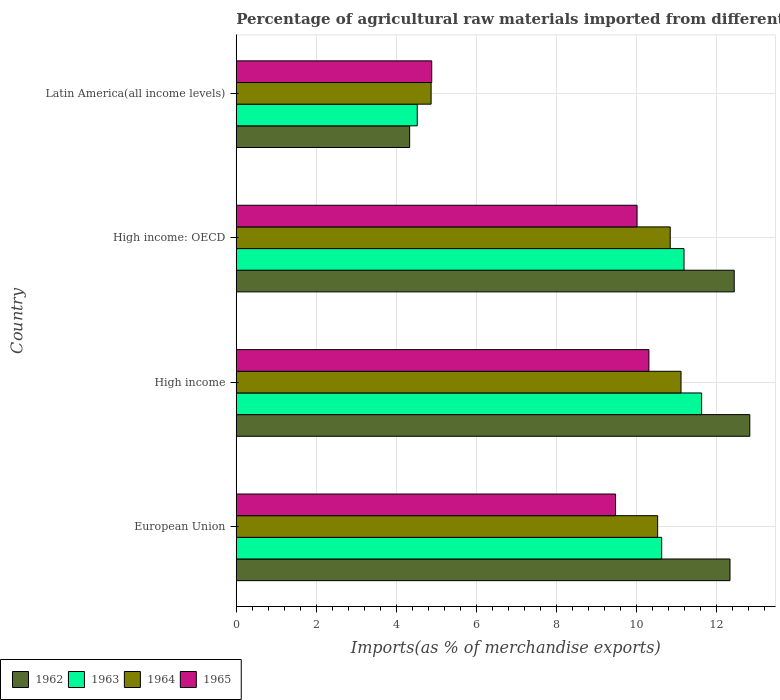How many different coloured bars are there?
Provide a succinct answer. 4. How many bars are there on the 2nd tick from the top?
Give a very brief answer. 4. How many bars are there on the 1st tick from the bottom?
Keep it short and to the point. 4. What is the percentage of imports to different countries in 1965 in High income: OECD?
Make the answer very short. 10.02. Across all countries, what is the maximum percentage of imports to different countries in 1964?
Your answer should be compact. 11.12. Across all countries, what is the minimum percentage of imports to different countries in 1963?
Your answer should be compact. 4.52. In which country was the percentage of imports to different countries in 1963 maximum?
Provide a succinct answer. High income. In which country was the percentage of imports to different countries in 1963 minimum?
Provide a succinct answer. Latin America(all income levels). What is the total percentage of imports to different countries in 1964 in the graph?
Your response must be concise. 37.37. What is the difference between the percentage of imports to different countries in 1964 in European Union and that in High income: OECD?
Your answer should be compact. -0.31. What is the difference between the percentage of imports to different countries in 1962 in Latin America(all income levels) and the percentage of imports to different countries in 1964 in High income?
Your answer should be compact. -6.78. What is the average percentage of imports to different countries in 1962 per country?
Give a very brief answer. 10.49. What is the difference between the percentage of imports to different countries in 1964 and percentage of imports to different countries in 1963 in European Union?
Offer a very short reply. -0.1. What is the ratio of the percentage of imports to different countries in 1963 in High income to that in High income: OECD?
Offer a terse response. 1.04. Is the percentage of imports to different countries in 1962 in European Union less than that in High income?
Offer a very short reply. Yes. What is the difference between the highest and the second highest percentage of imports to different countries in 1962?
Your answer should be very brief. 0.39. What is the difference between the highest and the lowest percentage of imports to different countries in 1965?
Keep it short and to the point. 5.43. Is it the case that in every country, the sum of the percentage of imports to different countries in 1965 and percentage of imports to different countries in 1962 is greater than the sum of percentage of imports to different countries in 1963 and percentage of imports to different countries in 1964?
Keep it short and to the point. No. What does the 1st bar from the top in Latin America(all income levels) represents?
Your response must be concise. 1965. What does the 3rd bar from the bottom in European Union represents?
Keep it short and to the point. 1964. How many bars are there?
Provide a succinct answer. 16. Are all the bars in the graph horizontal?
Your answer should be compact. Yes. How many countries are there in the graph?
Your response must be concise. 4. What is the difference between two consecutive major ticks on the X-axis?
Provide a succinct answer. 2. Are the values on the major ticks of X-axis written in scientific E-notation?
Your response must be concise. No. Does the graph contain any zero values?
Offer a very short reply. No. Does the graph contain grids?
Ensure brevity in your answer.  Yes. Where does the legend appear in the graph?
Provide a short and direct response. Bottom left. How many legend labels are there?
Offer a very short reply. 4. How are the legend labels stacked?
Ensure brevity in your answer.  Horizontal. What is the title of the graph?
Ensure brevity in your answer.  Percentage of agricultural raw materials imported from different countries. What is the label or title of the X-axis?
Offer a terse response. Imports(as % of merchandise exports). What is the label or title of the Y-axis?
Offer a terse response. Country. What is the Imports(as % of merchandise exports) in 1962 in European Union?
Your response must be concise. 12.34. What is the Imports(as % of merchandise exports) in 1963 in European Union?
Provide a short and direct response. 10.63. What is the Imports(as % of merchandise exports) in 1964 in European Union?
Provide a succinct answer. 10.53. What is the Imports(as % of merchandise exports) in 1965 in European Union?
Give a very brief answer. 9.48. What is the Imports(as % of merchandise exports) of 1962 in High income?
Ensure brevity in your answer.  12.84. What is the Imports(as % of merchandise exports) of 1963 in High income?
Your answer should be compact. 11.63. What is the Imports(as % of merchandise exports) in 1964 in High income?
Your answer should be compact. 11.12. What is the Imports(as % of merchandise exports) of 1965 in High income?
Make the answer very short. 10.31. What is the Imports(as % of merchandise exports) in 1962 in High income: OECD?
Offer a very short reply. 12.45. What is the Imports(as % of merchandise exports) of 1963 in High income: OECD?
Keep it short and to the point. 11.19. What is the Imports(as % of merchandise exports) in 1964 in High income: OECD?
Your answer should be very brief. 10.85. What is the Imports(as % of merchandise exports) of 1965 in High income: OECD?
Your answer should be compact. 10.02. What is the Imports(as % of merchandise exports) of 1962 in Latin America(all income levels)?
Your answer should be compact. 4.33. What is the Imports(as % of merchandise exports) in 1963 in Latin America(all income levels)?
Give a very brief answer. 4.52. What is the Imports(as % of merchandise exports) of 1964 in Latin America(all income levels)?
Provide a short and direct response. 4.87. What is the Imports(as % of merchandise exports) of 1965 in Latin America(all income levels)?
Keep it short and to the point. 4.89. Across all countries, what is the maximum Imports(as % of merchandise exports) in 1962?
Offer a very short reply. 12.84. Across all countries, what is the maximum Imports(as % of merchandise exports) of 1963?
Give a very brief answer. 11.63. Across all countries, what is the maximum Imports(as % of merchandise exports) of 1964?
Provide a succinct answer. 11.12. Across all countries, what is the maximum Imports(as % of merchandise exports) in 1965?
Ensure brevity in your answer.  10.31. Across all countries, what is the minimum Imports(as % of merchandise exports) in 1962?
Give a very brief answer. 4.33. Across all countries, what is the minimum Imports(as % of merchandise exports) of 1963?
Your response must be concise. 4.52. Across all countries, what is the minimum Imports(as % of merchandise exports) in 1964?
Your answer should be compact. 4.87. Across all countries, what is the minimum Imports(as % of merchandise exports) in 1965?
Offer a terse response. 4.89. What is the total Imports(as % of merchandise exports) of 1962 in the graph?
Keep it short and to the point. 41.96. What is the total Imports(as % of merchandise exports) in 1963 in the graph?
Make the answer very short. 37.98. What is the total Imports(as % of merchandise exports) of 1964 in the graph?
Offer a terse response. 37.37. What is the total Imports(as % of merchandise exports) of 1965 in the graph?
Offer a terse response. 34.7. What is the difference between the Imports(as % of merchandise exports) in 1962 in European Union and that in High income?
Keep it short and to the point. -0.5. What is the difference between the Imports(as % of merchandise exports) in 1963 in European Union and that in High income?
Ensure brevity in your answer.  -1. What is the difference between the Imports(as % of merchandise exports) of 1964 in European Union and that in High income?
Offer a very short reply. -0.58. What is the difference between the Imports(as % of merchandise exports) of 1965 in European Union and that in High income?
Ensure brevity in your answer.  -0.83. What is the difference between the Imports(as % of merchandise exports) of 1962 in European Union and that in High income: OECD?
Your response must be concise. -0.11. What is the difference between the Imports(as % of merchandise exports) of 1963 in European Union and that in High income: OECD?
Provide a succinct answer. -0.56. What is the difference between the Imports(as % of merchandise exports) of 1964 in European Union and that in High income: OECD?
Provide a short and direct response. -0.31. What is the difference between the Imports(as % of merchandise exports) of 1965 in European Union and that in High income: OECD?
Keep it short and to the point. -0.54. What is the difference between the Imports(as % of merchandise exports) of 1962 in European Union and that in Latin America(all income levels)?
Offer a terse response. 8.01. What is the difference between the Imports(as % of merchandise exports) of 1963 in European Union and that in Latin America(all income levels)?
Provide a short and direct response. 6.11. What is the difference between the Imports(as % of merchandise exports) in 1964 in European Union and that in Latin America(all income levels)?
Give a very brief answer. 5.66. What is the difference between the Imports(as % of merchandise exports) in 1965 in European Union and that in Latin America(all income levels)?
Offer a very short reply. 4.59. What is the difference between the Imports(as % of merchandise exports) of 1962 in High income and that in High income: OECD?
Ensure brevity in your answer.  0.39. What is the difference between the Imports(as % of merchandise exports) of 1963 in High income and that in High income: OECD?
Keep it short and to the point. 0.44. What is the difference between the Imports(as % of merchandise exports) in 1964 in High income and that in High income: OECD?
Ensure brevity in your answer.  0.27. What is the difference between the Imports(as % of merchandise exports) in 1965 in High income and that in High income: OECD?
Your response must be concise. 0.3. What is the difference between the Imports(as % of merchandise exports) of 1962 in High income and that in Latin America(all income levels)?
Your answer should be compact. 8.5. What is the difference between the Imports(as % of merchandise exports) in 1963 in High income and that in Latin America(all income levels)?
Provide a succinct answer. 7.11. What is the difference between the Imports(as % of merchandise exports) of 1964 in High income and that in Latin America(all income levels)?
Keep it short and to the point. 6.25. What is the difference between the Imports(as % of merchandise exports) of 1965 in High income and that in Latin America(all income levels)?
Your answer should be compact. 5.43. What is the difference between the Imports(as % of merchandise exports) in 1962 in High income: OECD and that in Latin America(all income levels)?
Provide a short and direct response. 8.11. What is the difference between the Imports(as % of merchandise exports) of 1963 in High income: OECD and that in Latin America(all income levels)?
Provide a short and direct response. 6.67. What is the difference between the Imports(as % of merchandise exports) of 1964 in High income: OECD and that in Latin America(all income levels)?
Your response must be concise. 5.98. What is the difference between the Imports(as % of merchandise exports) of 1965 in High income: OECD and that in Latin America(all income levels)?
Your answer should be very brief. 5.13. What is the difference between the Imports(as % of merchandise exports) of 1962 in European Union and the Imports(as % of merchandise exports) of 1963 in High income?
Keep it short and to the point. 0.71. What is the difference between the Imports(as % of merchandise exports) in 1962 in European Union and the Imports(as % of merchandise exports) in 1964 in High income?
Offer a very short reply. 1.22. What is the difference between the Imports(as % of merchandise exports) in 1962 in European Union and the Imports(as % of merchandise exports) in 1965 in High income?
Your answer should be compact. 2.03. What is the difference between the Imports(as % of merchandise exports) of 1963 in European Union and the Imports(as % of merchandise exports) of 1964 in High income?
Offer a terse response. -0.48. What is the difference between the Imports(as % of merchandise exports) of 1963 in European Union and the Imports(as % of merchandise exports) of 1965 in High income?
Keep it short and to the point. 0.32. What is the difference between the Imports(as % of merchandise exports) in 1964 in European Union and the Imports(as % of merchandise exports) in 1965 in High income?
Keep it short and to the point. 0.22. What is the difference between the Imports(as % of merchandise exports) in 1962 in European Union and the Imports(as % of merchandise exports) in 1963 in High income: OECD?
Ensure brevity in your answer.  1.15. What is the difference between the Imports(as % of merchandise exports) in 1962 in European Union and the Imports(as % of merchandise exports) in 1964 in High income: OECD?
Your answer should be very brief. 1.49. What is the difference between the Imports(as % of merchandise exports) of 1962 in European Union and the Imports(as % of merchandise exports) of 1965 in High income: OECD?
Make the answer very short. 2.32. What is the difference between the Imports(as % of merchandise exports) in 1963 in European Union and the Imports(as % of merchandise exports) in 1964 in High income: OECD?
Offer a very short reply. -0.21. What is the difference between the Imports(as % of merchandise exports) in 1963 in European Union and the Imports(as % of merchandise exports) in 1965 in High income: OECD?
Offer a very short reply. 0.62. What is the difference between the Imports(as % of merchandise exports) in 1964 in European Union and the Imports(as % of merchandise exports) in 1965 in High income: OECD?
Your response must be concise. 0.51. What is the difference between the Imports(as % of merchandise exports) of 1962 in European Union and the Imports(as % of merchandise exports) of 1963 in Latin America(all income levels)?
Offer a terse response. 7.82. What is the difference between the Imports(as % of merchandise exports) of 1962 in European Union and the Imports(as % of merchandise exports) of 1964 in Latin America(all income levels)?
Ensure brevity in your answer.  7.47. What is the difference between the Imports(as % of merchandise exports) in 1962 in European Union and the Imports(as % of merchandise exports) in 1965 in Latin America(all income levels)?
Offer a very short reply. 7.46. What is the difference between the Imports(as % of merchandise exports) in 1963 in European Union and the Imports(as % of merchandise exports) in 1964 in Latin America(all income levels)?
Give a very brief answer. 5.76. What is the difference between the Imports(as % of merchandise exports) of 1963 in European Union and the Imports(as % of merchandise exports) of 1965 in Latin America(all income levels)?
Ensure brevity in your answer.  5.75. What is the difference between the Imports(as % of merchandise exports) in 1964 in European Union and the Imports(as % of merchandise exports) in 1965 in Latin America(all income levels)?
Provide a succinct answer. 5.65. What is the difference between the Imports(as % of merchandise exports) in 1962 in High income and the Imports(as % of merchandise exports) in 1963 in High income: OECD?
Keep it short and to the point. 1.64. What is the difference between the Imports(as % of merchandise exports) of 1962 in High income and the Imports(as % of merchandise exports) of 1964 in High income: OECD?
Make the answer very short. 1.99. What is the difference between the Imports(as % of merchandise exports) in 1962 in High income and the Imports(as % of merchandise exports) in 1965 in High income: OECD?
Offer a very short reply. 2.82. What is the difference between the Imports(as % of merchandise exports) in 1963 in High income and the Imports(as % of merchandise exports) in 1964 in High income: OECD?
Your answer should be compact. 0.78. What is the difference between the Imports(as % of merchandise exports) of 1963 in High income and the Imports(as % of merchandise exports) of 1965 in High income: OECD?
Offer a very short reply. 1.61. What is the difference between the Imports(as % of merchandise exports) in 1964 in High income and the Imports(as % of merchandise exports) in 1965 in High income: OECD?
Give a very brief answer. 1.1. What is the difference between the Imports(as % of merchandise exports) of 1962 in High income and the Imports(as % of merchandise exports) of 1963 in Latin America(all income levels)?
Keep it short and to the point. 8.31. What is the difference between the Imports(as % of merchandise exports) of 1962 in High income and the Imports(as % of merchandise exports) of 1964 in Latin America(all income levels)?
Provide a short and direct response. 7.97. What is the difference between the Imports(as % of merchandise exports) of 1962 in High income and the Imports(as % of merchandise exports) of 1965 in Latin America(all income levels)?
Provide a short and direct response. 7.95. What is the difference between the Imports(as % of merchandise exports) in 1963 in High income and the Imports(as % of merchandise exports) in 1964 in Latin America(all income levels)?
Give a very brief answer. 6.76. What is the difference between the Imports(as % of merchandise exports) of 1963 in High income and the Imports(as % of merchandise exports) of 1965 in Latin America(all income levels)?
Give a very brief answer. 6.75. What is the difference between the Imports(as % of merchandise exports) of 1964 in High income and the Imports(as % of merchandise exports) of 1965 in Latin America(all income levels)?
Provide a short and direct response. 6.23. What is the difference between the Imports(as % of merchandise exports) in 1962 in High income: OECD and the Imports(as % of merchandise exports) in 1963 in Latin America(all income levels)?
Provide a short and direct response. 7.92. What is the difference between the Imports(as % of merchandise exports) of 1962 in High income: OECD and the Imports(as % of merchandise exports) of 1964 in Latin America(all income levels)?
Your answer should be compact. 7.58. What is the difference between the Imports(as % of merchandise exports) in 1962 in High income: OECD and the Imports(as % of merchandise exports) in 1965 in Latin America(all income levels)?
Give a very brief answer. 7.56. What is the difference between the Imports(as % of merchandise exports) in 1963 in High income: OECD and the Imports(as % of merchandise exports) in 1964 in Latin America(all income levels)?
Give a very brief answer. 6.32. What is the difference between the Imports(as % of merchandise exports) in 1963 in High income: OECD and the Imports(as % of merchandise exports) in 1965 in Latin America(all income levels)?
Your answer should be compact. 6.31. What is the difference between the Imports(as % of merchandise exports) in 1964 in High income: OECD and the Imports(as % of merchandise exports) in 1965 in Latin America(all income levels)?
Your answer should be very brief. 5.96. What is the average Imports(as % of merchandise exports) in 1962 per country?
Offer a terse response. 10.49. What is the average Imports(as % of merchandise exports) in 1963 per country?
Offer a terse response. 9.5. What is the average Imports(as % of merchandise exports) in 1964 per country?
Provide a succinct answer. 9.34. What is the average Imports(as % of merchandise exports) of 1965 per country?
Make the answer very short. 8.67. What is the difference between the Imports(as % of merchandise exports) in 1962 and Imports(as % of merchandise exports) in 1963 in European Union?
Keep it short and to the point. 1.71. What is the difference between the Imports(as % of merchandise exports) of 1962 and Imports(as % of merchandise exports) of 1964 in European Union?
Give a very brief answer. 1.81. What is the difference between the Imports(as % of merchandise exports) in 1962 and Imports(as % of merchandise exports) in 1965 in European Union?
Give a very brief answer. 2.86. What is the difference between the Imports(as % of merchandise exports) in 1963 and Imports(as % of merchandise exports) in 1964 in European Union?
Provide a short and direct response. 0.1. What is the difference between the Imports(as % of merchandise exports) of 1963 and Imports(as % of merchandise exports) of 1965 in European Union?
Your answer should be compact. 1.15. What is the difference between the Imports(as % of merchandise exports) of 1964 and Imports(as % of merchandise exports) of 1965 in European Union?
Your answer should be compact. 1.05. What is the difference between the Imports(as % of merchandise exports) of 1962 and Imports(as % of merchandise exports) of 1963 in High income?
Provide a short and direct response. 1.2. What is the difference between the Imports(as % of merchandise exports) of 1962 and Imports(as % of merchandise exports) of 1964 in High income?
Your answer should be very brief. 1.72. What is the difference between the Imports(as % of merchandise exports) of 1962 and Imports(as % of merchandise exports) of 1965 in High income?
Offer a terse response. 2.52. What is the difference between the Imports(as % of merchandise exports) of 1963 and Imports(as % of merchandise exports) of 1964 in High income?
Provide a succinct answer. 0.52. What is the difference between the Imports(as % of merchandise exports) of 1963 and Imports(as % of merchandise exports) of 1965 in High income?
Provide a succinct answer. 1.32. What is the difference between the Imports(as % of merchandise exports) in 1964 and Imports(as % of merchandise exports) in 1965 in High income?
Ensure brevity in your answer.  0.8. What is the difference between the Imports(as % of merchandise exports) of 1962 and Imports(as % of merchandise exports) of 1963 in High income: OECD?
Make the answer very short. 1.25. What is the difference between the Imports(as % of merchandise exports) of 1962 and Imports(as % of merchandise exports) of 1964 in High income: OECD?
Provide a short and direct response. 1.6. What is the difference between the Imports(as % of merchandise exports) of 1962 and Imports(as % of merchandise exports) of 1965 in High income: OECD?
Provide a short and direct response. 2.43. What is the difference between the Imports(as % of merchandise exports) of 1963 and Imports(as % of merchandise exports) of 1964 in High income: OECD?
Keep it short and to the point. 0.34. What is the difference between the Imports(as % of merchandise exports) in 1963 and Imports(as % of merchandise exports) in 1965 in High income: OECD?
Offer a very short reply. 1.17. What is the difference between the Imports(as % of merchandise exports) in 1964 and Imports(as % of merchandise exports) in 1965 in High income: OECD?
Provide a succinct answer. 0.83. What is the difference between the Imports(as % of merchandise exports) in 1962 and Imports(as % of merchandise exports) in 1963 in Latin America(all income levels)?
Keep it short and to the point. -0.19. What is the difference between the Imports(as % of merchandise exports) of 1962 and Imports(as % of merchandise exports) of 1964 in Latin America(all income levels)?
Provide a succinct answer. -0.54. What is the difference between the Imports(as % of merchandise exports) of 1962 and Imports(as % of merchandise exports) of 1965 in Latin America(all income levels)?
Make the answer very short. -0.55. What is the difference between the Imports(as % of merchandise exports) in 1963 and Imports(as % of merchandise exports) in 1964 in Latin America(all income levels)?
Make the answer very short. -0.35. What is the difference between the Imports(as % of merchandise exports) in 1963 and Imports(as % of merchandise exports) in 1965 in Latin America(all income levels)?
Ensure brevity in your answer.  -0.36. What is the difference between the Imports(as % of merchandise exports) in 1964 and Imports(as % of merchandise exports) in 1965 in Latin America(all income levels)?
Your answer should be very brief. -0.02. What is the ratio of the Imports(as % of merchandise exports) in 1962 in European Union to that in High income?
Offer a terse response. 0.96. What is the ratio of the Imports(as % of merchandise exports) in 1963 in European Union to that in High income?
Your answer should be compact. 0.91. What is the ratio of the Imports(as % of merchandise exports) of 1964 in European Union to that in High income?
Ensure brevity in your answer.  0.95. What is the ratio of the Imports(as % of merchandise exports) of 1965 in European Union to that in High income?
Keep it short and to the point. 0.92. What is the ratio of the Imports(as % of merchandise exports) in 1962 in European Union to that in High income: OECD?
Offer a very short reply. 0.99. What is the ratio of the Imports(as % of merchandise exports) in 1963 in European Union to that in High income: OECD?
Your answer should be very brief. 0.95. What is the ratio of the Imports(as % of merchandise exports) of 1965 in European Union to that in High income: OECD?
Make the answer very short. 0.95. What is the ratio of the Imports(as % of merchandise exports) of 1962 in European Union to that in Latin America(all income levels)?
Your response must be concise. 2.85. What is the ratio of the Imports(as % of merchandise exports) in 1963 in European Union to that in Latin America(all income levels)?
Give a very brief answer. 2.35. What is the ratio of the Imports(as % of merchandise exports) in 1964 in European Union to that in Latin America(all income levels)?
Provide a short and direct response. 2.16. What is the ratio of the Imports(as % of merchandise exports) in 1965 in European Union to that in Latin America(all income levels)?
Offer a very short reply. 1.94. What is the ratio of the Imports(as % of merchandise exports) of 1962 in High income to that in High income: OECD?
Provide a short and direct response. 1.03. What is the ratio of the Imports(as % of merchandise exports) of 1963 in High income to that in High income: OECD?
Keep it short and to the point. 1.04. What is the ratio of the Imports(as % of merchandise exports) in 1964 in High income to that in High income: OECD?
Offer a terse response. 1.02. What is the ratio of the Imports(as % of merchandise exports) in 1965 in High income to that in High income: OECD?
Your response must be concise. 1.03. What is the ratio of the Imports(as % of merchandise exports) of 1962 in High income to that in Latin America(all income levels)?
Keep it short and to the point. 2.96. What is the ratio of the Imports(as % of merchandise exports) of 1963 in High income to that in Latin America(all income levels)?
Your answer should be very brief. 2.57. What is the ratio of the Imports(as % of merchandise exports) of 1964 in High income to that in Latin America(all income levels)?
Your response must be concise. 2.28. What is the ratio of the Imports(as % of merchandise exports) of 1965 in High income to that in Latin America(all income levels)?
Give a very brief answer. 2.11. What is the ratio of the Imports(as % of merchandise exports) in 1962 in High income: OECD to that in Latin America(all income levels)?
Offer a very short reply. 2.87. What is the ratio of the Imports(as % of merchandise exports) in 1963 in High income: OECD to that in Latin America(all income levels)?
Your response must be concise. 2.47. What is the ratio of the Imports(as % of merchandise exports) of 1964 in High income: OECD to that in Latin America(all income levels)?
Your response must be concise. 2.23. What is the ratio of the Imports(as % of merchandise exports) of 1965 in High income: OECD to that in Latin America(all income levels)?
Your answer should be compact. 2.05. What is the difference between the highest and the second highest Imports(as % of merchandise exports) of 1962?
Your response must be concise. 0.39. What is the difference between the highest and the second highest Imports(as % of merchandise exports) of 1963?
Make the answer very short. 0.44. What is the difference between the highest and the second highest Imports(as % of merchandise exports) in 1964?
Keep it short and to the point. 0.27. What is the difference between the highest and the second highest Imports(as % of merchandise exports) of 1965?
Ensure brevity in your answer.  0.3. What is the difference between the highest and the lowest Imports(as % of merchandise exports) in 1962?
Offer a terse response. 8.5. What is the difference between the highest and the lowest Imports(as % of merchandise exports) in 1963?
Ensure brevity in your answer.  7.11. What is the difference between the highest and the lowest Imports(as % of merchandise exports) in 1964?
Keep it short and to the point. 6.25. What is the difference between the highest and the lowest Imports(as % of merchandise exports) in 1965?
Keep it short and to the point. 5.43. 